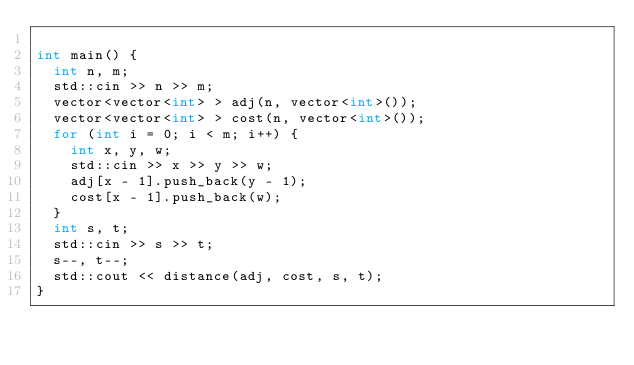<code> <loc_0><loc_0><loc_500><loc_500><_C++_>
int main() {
  int n, m;
  std::cin >> n >> m;
  vector<vector<int> > adj(n, vector<int>());
  vector<vector<int> > cost(n, vector<int>());
  for (int i = 0; i < m; i++) {
    int x, y, w;
    std::cin >> x >> y >> w;
    adj[x - 1].push_back(y - 1);
    cost[x - 1].push_back(w);
  }
  int s, t;
  std::cin >> s >> t;
  s--, t--;
  std::cout << distance(adj, cost, s, t);
}
</code> 